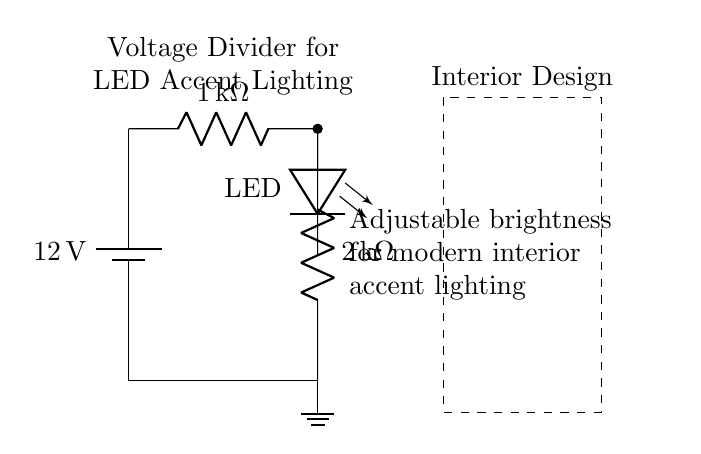What is the total resistance in the voltage divider? The total resistance in a voltage divider is the sum of the resistances in series. Here, it is the 1kΩ and 2kΩ resistors combined: 1kΩ + 2kΩ = 3kΩ.
Answer: 3kΩ What is the voltage supplied to the circuit? The circuit is supplied with a battery that has a voltage of 12 volts, indicated clearly by the battery label.
Answer: 12 volts What is the value of the first resistor in the divider? The first resistor is labeled as 1kΩ, which indicates its resistance value directly in the circuit diagram.
Answer: 1kΩ What type of component is used for lighting in this circuit? The component used for lighting in this circuit is an LED, as denoted by the symbol and label in the diagram.
Answer: LED What is the purpose of the voltage divider in this circuit? The voltage divider’s purpose is to reduce the voltage to a level suitable for the LED, allowing it to illuminate at lower brightness levels, as indicated in the description next to the circuit.
Answer: Adjustable brightness What type of circuit is this an example of? This is an example of an analog circuit as it uses resistors and an LED to control voltage for lighting.
Answer: Analog circuit What is the function of the ground in the circuit? The ground serves as the reference point for the circuit and completes the electrical connection, ensuring that the current can flow through the circuit back to the battery.
Answer: Reference point 